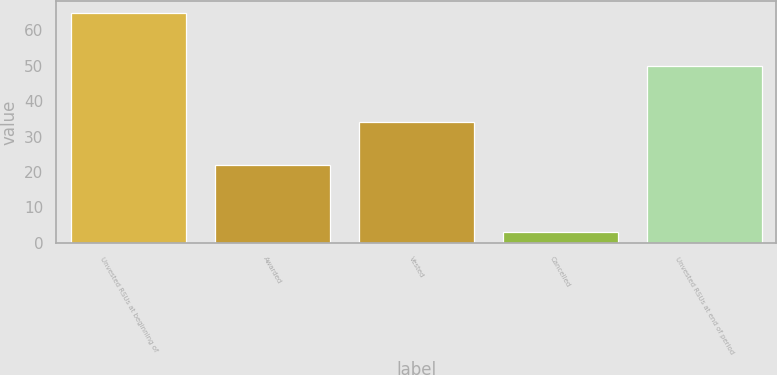Convert chart. <chart><loc_0><loc_0><loc_500><loc_500><bar_chart><fcel>Unvested RSUs at beginning of<fcel>Awarded<fcel>Vested<fcel>Cancelled<fcel>Unvested RSUs at end of period<nl><fcel>65<fcel>22<fcel>34<fcel>3<fcel>50<nl></chart> 